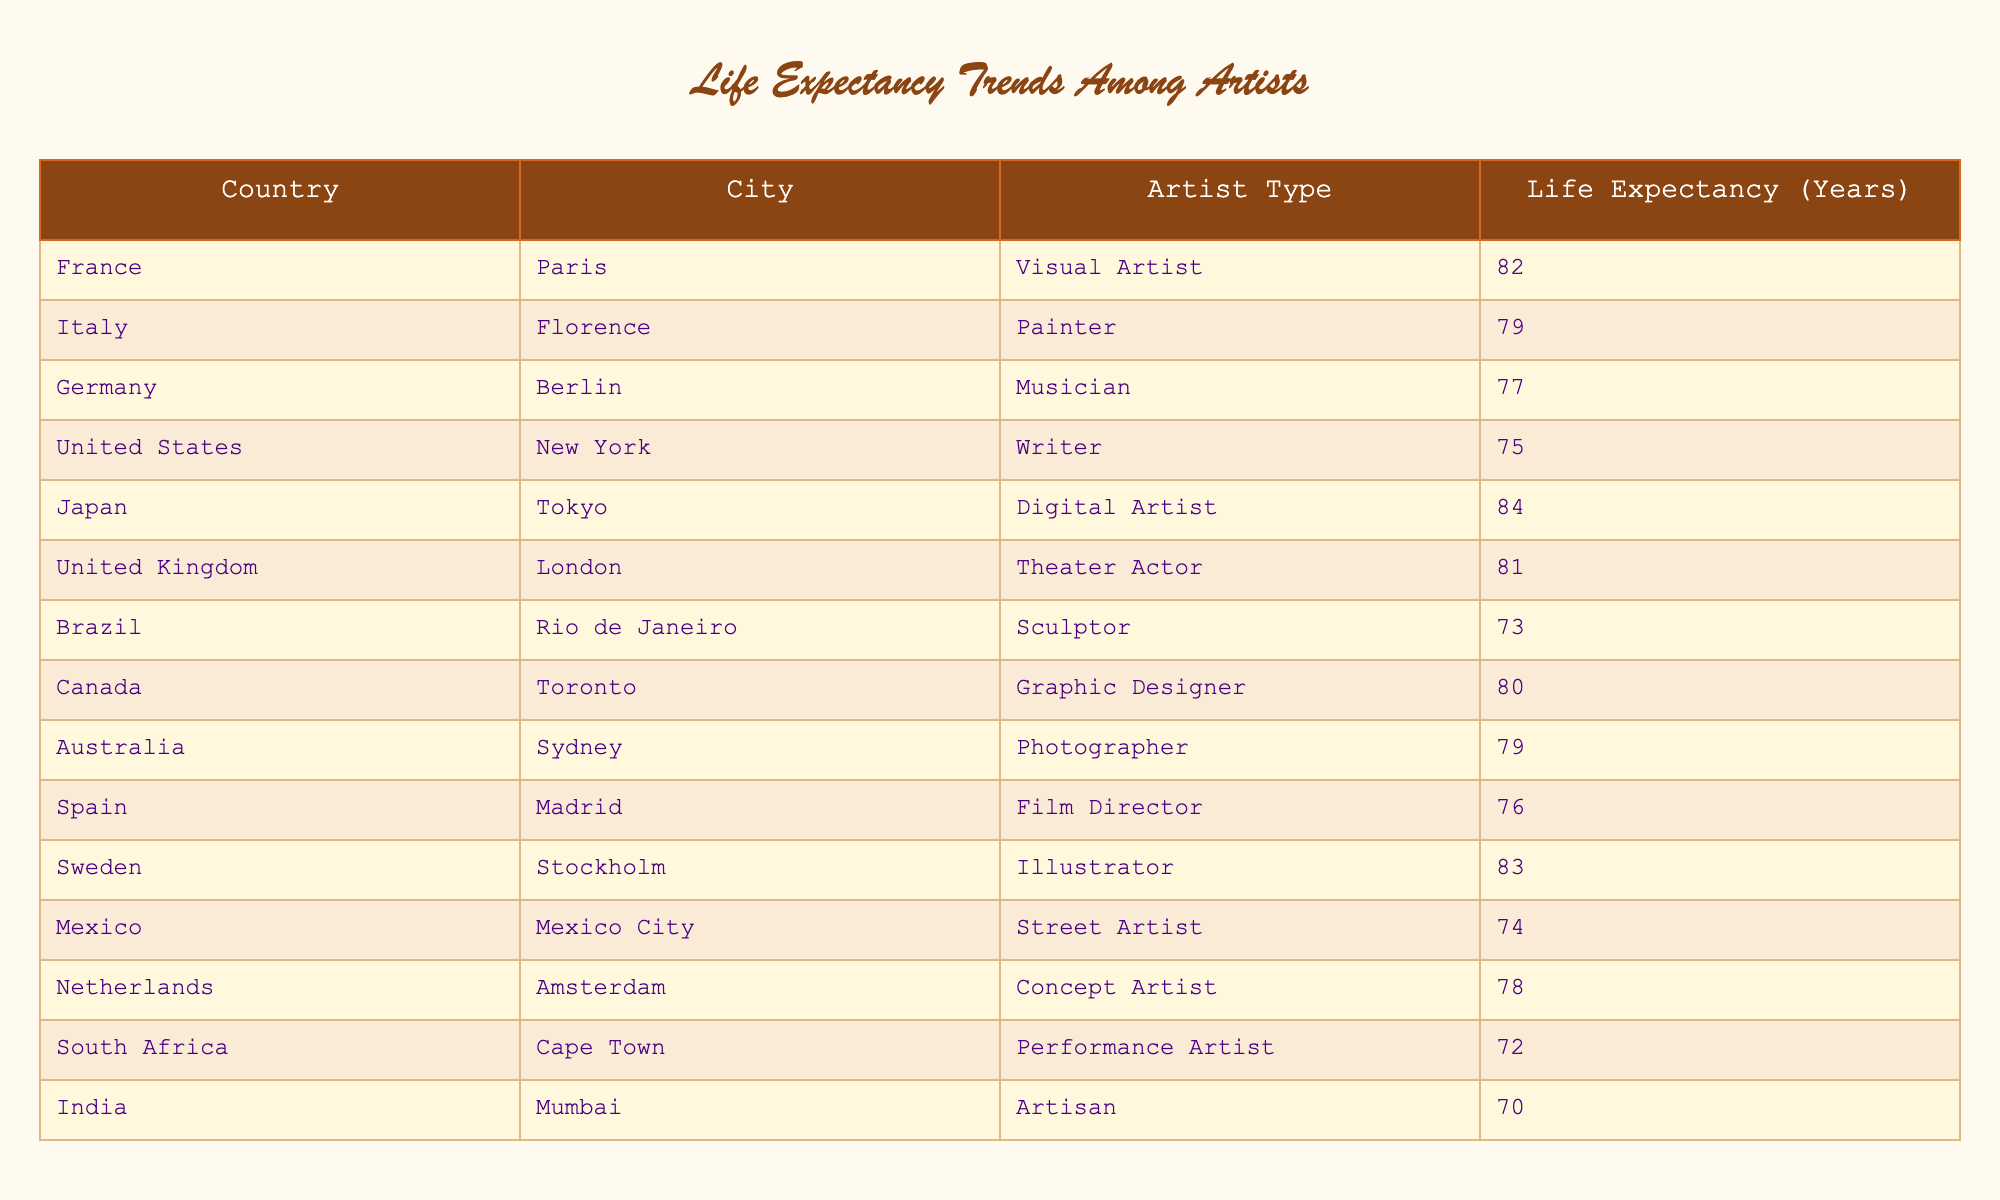What is the life expectancy of visual artists in Paris? According to the table, the life expectancy for visual artists in Paris is directly listed as 82 years.
Answer: 82 Which artist type in Tokyo has the highest life expectancy? The table indicates that a digital artist in Tokyo has a life expectancy of 84 years, which is higher than other artist types listed for Tokyo.
Answer: 84 What is the average life expectancy of artists in Europe (France, Italy, Germany, United Kingdom, Netherlands, and Sweden)? The life expectancies for artists in these countries are 82 (France), 79 (Italy), 77 (Germany), 81 (United Kingdom), 78 (Netherlands), and 83 (Sweden). Summing these values gives a total of 480 years, then dividing by 6 (the number of countries) results in an average of 80 years.
Answer: 80 Are artists in Cape Town and Mumbai more likely to have a higher life expectancy than those in New York? The life expectancy for performance artists in Cape Town is 72 years, and for artisans in Mumbai, it is 70 years. Both are lower than the 75-year life expectancy for writers in New York. Therefore, the statement is false.
Answer: No Which country has the lowest life expectancy for artists according to the table? From the table, the artisan in Mumbai has the lowest life expectancy at 70 years compared to others listed, making India rank the lowest for artist life expectancy.
Answer: India What is the difference in life expectancy between street artists in Mexico City and musicians in Berlin? The life expectancy for street artists in Mexico City is 74 years, while musicians in Berlin have a life expectancy of 77 years. Calculating the difference: 77 - 74 = 3 years.
Answer: 3 Which city has the highest life expectancy among artists listed? The data shows that the digital artist in Tokyo has the highest life expectancy at 84 years, making Tokyo the city with the highest life expectancy for artists.
Answer: Tokyo Is the life expectancy of graphic designers in Toronto lower than that of photographers in Sydney? The table lists the life expectancy of graphic designers in Toronto as 80 years and photographers in Sydney as 79 years. Since 80 is greater than 79, the statement is false.
Answer: No How many artists listed have a life expectancy over 80 years? The artists with life expectancies over 80 years are the visual artist in Paris (82), digital artist in Tokyo (84), theater actor in London (81), and illustrator in Stockholm (83). That makes a total of 4 artists.
Answer: 4 